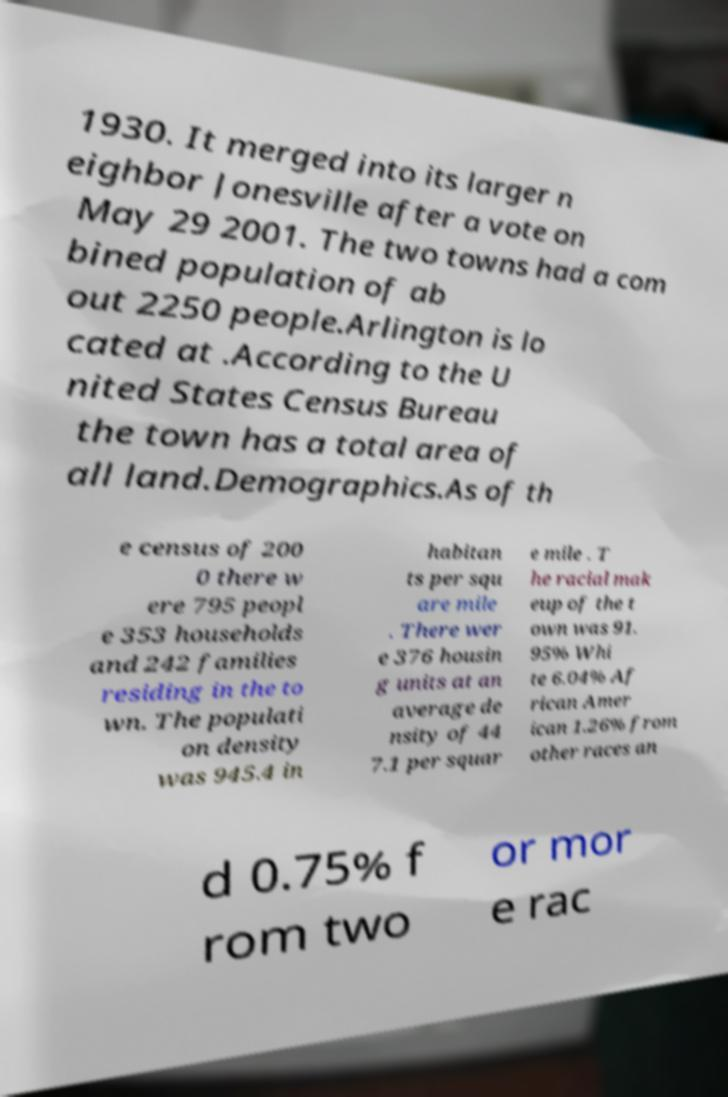Could you assist in decoding the text presented in this image and type it out clearly? 1930. It merged into its larger n eighbor Jonesville after a vote on May 29 2001. The two towns had a com bined population of ab out 2250 people.Arlington is lo cated at .According to the U nited States Census Bureau the town has a total area of all land.Demographics.As of th e census of 200 0 there w ere 795 peopl e 353 households and 242 families residing in the to wn. The populati on density was 945.4 in habitan ts per squ are mile . There wer e 376 housin g units at an average de nsity of 44 7.1 per squar e mile . T he racial mak eup of the t own was 91. 95% Whi te 6.04% Af rican Amer ican 1.26% from other races an d 0.75% f rom two or mor e rac 